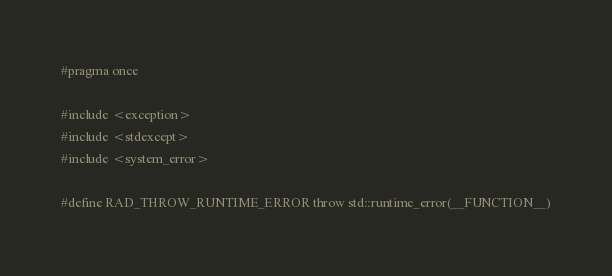<code> <loc_0><loc_0><loc_500><loc_500><_C_>#pragma once

#include <exception>
#include <stdexcept>
#include <system_error>

#define RAD_THROW_RUNTIME_ERROR throw std::runtime_error(__FUNCTION__)
</code> 